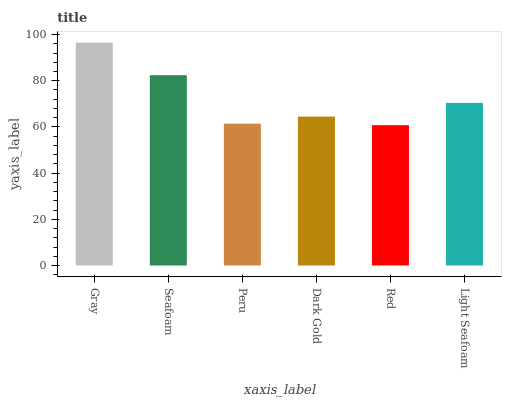Is Red the minimum?
Answer yes or no. Yes. Is Gray the maximum?
Answer yes or no. Yes. Is Seafoam the minimum?
Answer yes or no. No. Is Seafoam the maximum?
Answer yes or no. No. Is Gray greater than Seafoam?
Answer yes or no. Yes. Is Seafoam less than Gray?
Answer yes or no. Yes. Is Seafoam greater than Gray?
Answer yes or no. No. Is Gray less than Seafoam?
Answer yes or no. No. Is Light Seafoam the high median?
Answer yes or no. Yes. Is Dark Gold the low median?
Answer yes or no. Yes. Is Seafoam the high median?
Answer yes or no. No. Is Seafoam the low median?
Answer yes or no. No. 